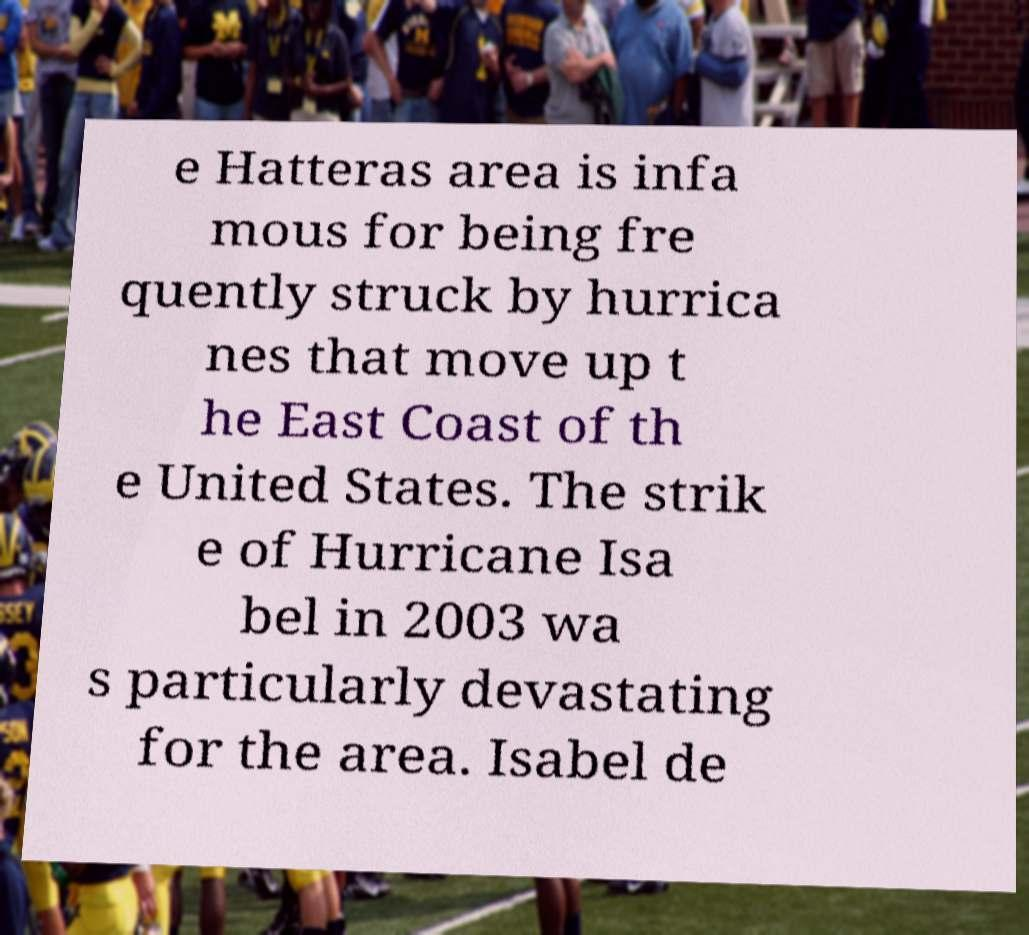Could you extract and type out the text from this image? e Hatteras area is infa mous for being fre quently struck by hurrica nes that move up t he East Coast of th e United States. The strik e of Hurricane Isa bel in 2003 wa s particularly devastating for the area. Isabel de 